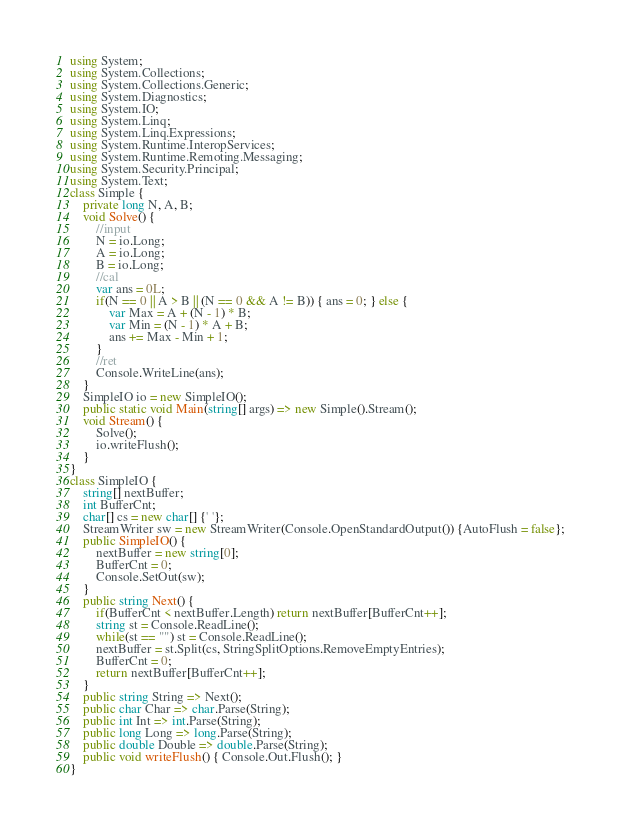Convert code to text. <code><loc_0><loc_0><loc_500><loc_500><_C#_>using System;
using System.Collections;
using System.Collections.Generic;
using System.Diagnostics;
using System.IO;
using System.Linq;
using System.Linq.Expressions;
using System.Runtime.InteropServices;
using System.Runtime.Remoting.Messaging;
using System.Security.Principal;
using System.Text;
class Simple {
    private long N, A, B;
    void Solve() {
        //input
        N = io.Long;
        A = io.Long;
        B = io.Long;
        //cal
        var ans = 0L;
        if(N == 0 || A > B || (N == 0 && A != B)) { ans = 0; } else {
            var Max = A + (N - 1) * B;
            var Min = (N - 1) * A + B;
            ans += Max - Min + 1;
        }
        //ret
        Console.WriteLine(ans);
    }
    SimpleIO io = new SimpleIO();
    public static void Main(string[] args) => new Simple().Stream();
    void Stream() {
        Solve();
        io.writeFlush();
    }
}
class SimpleIO {
    string[] nextBuffer;
    int BufferCnt;
    char[] cs = new char[] {' '};
    StreamWriter sw = new StreamWriter(Console.OpenStandardOutput()) {AutoFlush = false};
    public SimpleIO() {
        nextBuffer = new string[0];
        BufferCnt = 0;
        Console.SetOut(sw);
    }
    public string Next() {
        if(BufferCnt < nextBuffer.Length) return nextBuffer[BufferCnt++];
        string st = Console.ReadLine();
        while(st == "") st = Console.ReadLine();
        nextBuffer = st.Split(cs, StringSplitOptions.RemoveEmptyEntries);
        BufferCnt = 0;
        return nextBuffer[BufferCnt++];
    }
    public string String => Next();
    public char Char => char.Parse(String);
    public int Int => int.Parse(String);
    public long Long => long.Parse(String);
    public double Double => double.Parse(String);
    public void writeFlush() { Console.Out.Flush(); }
}
</code> 